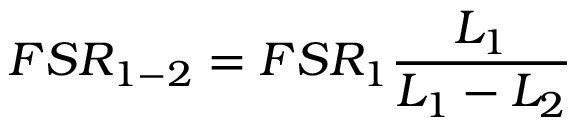Convert formula to latex. <formula><loc_0><loc_0><loc_500><loc_500>F S R _ { 1 - 2 } = F S R _ { 1 } \frac { L _ { 1 } } { L _ { 1 } - L _ { 2 } }</formula> 